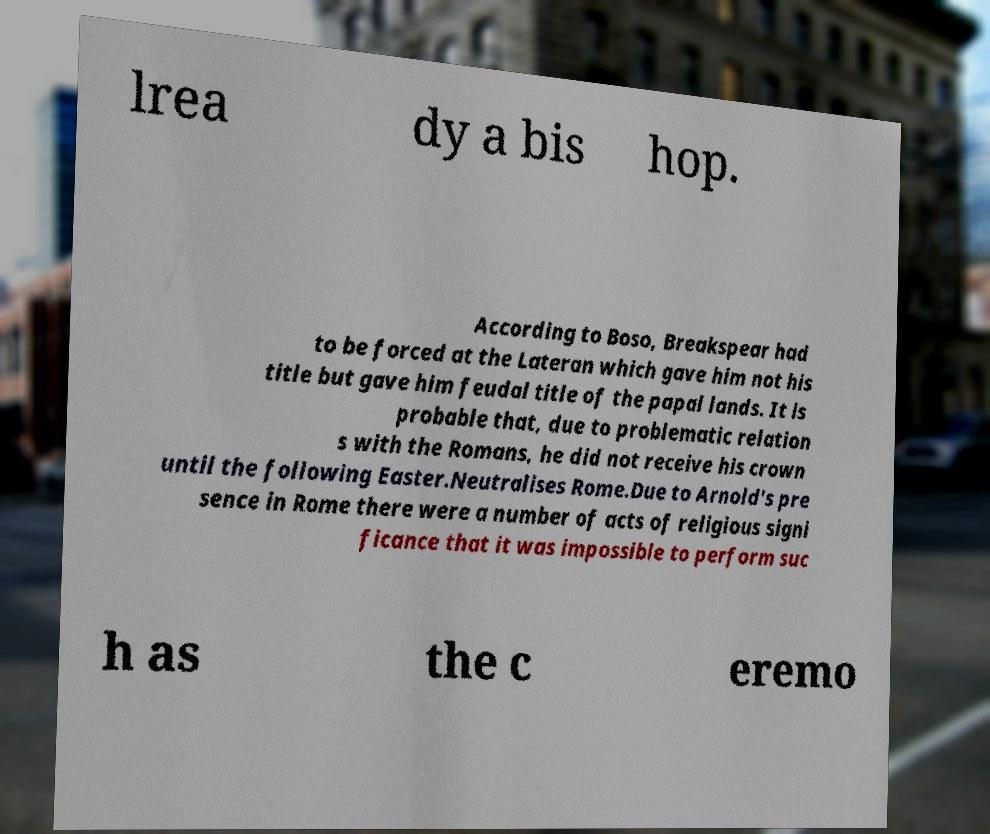Please read and relay the text visible in this image. What does it say? lrea dy a bis hop. According to Boso, Breakspear had to be forced at the Lateran which gave him not his title but gave him feudal title of the papal lands. It is probable that, due to problematic relation s with the Romans, he did not receive his crown until the following Easter.Neutralises Rome.Due to Arnold's pre sence in Rome there were a number of acts of religious signi ficance that it was impossible to perform suc h as the c eremo 